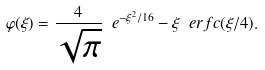<formula> <loc_0><loc_0><loc_500><loc_500>\varphi ( \xi ) = \frac { 4 } { \sqrt { \pi } } \ e ^ { - \xi ^ { 2 } / 1 6 } - \xi \ e r f c ( \xi / 4 ) .</formula> 